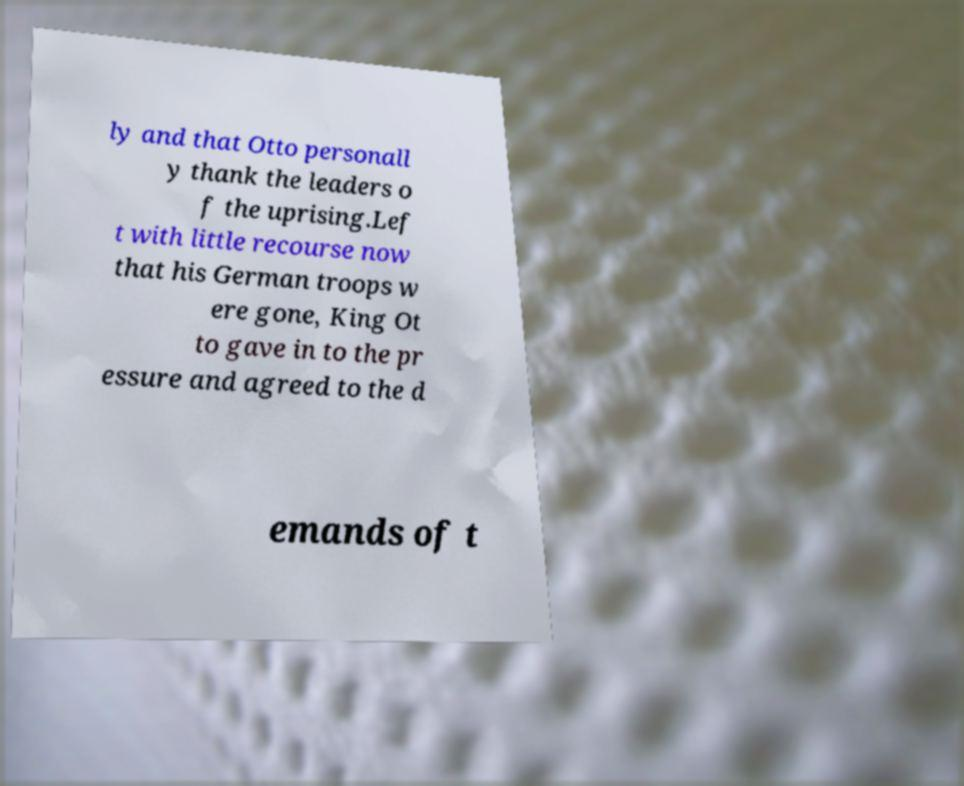There's text embedded in this image that I need extracted. Can you transcribe it verbatim? ly and that Otto personall y thank the leaders o f the uprising.Lef t with little recourse now that his German troops w ere gone, King Ot to gave in to the pr essure and agreed to the d emands of t 